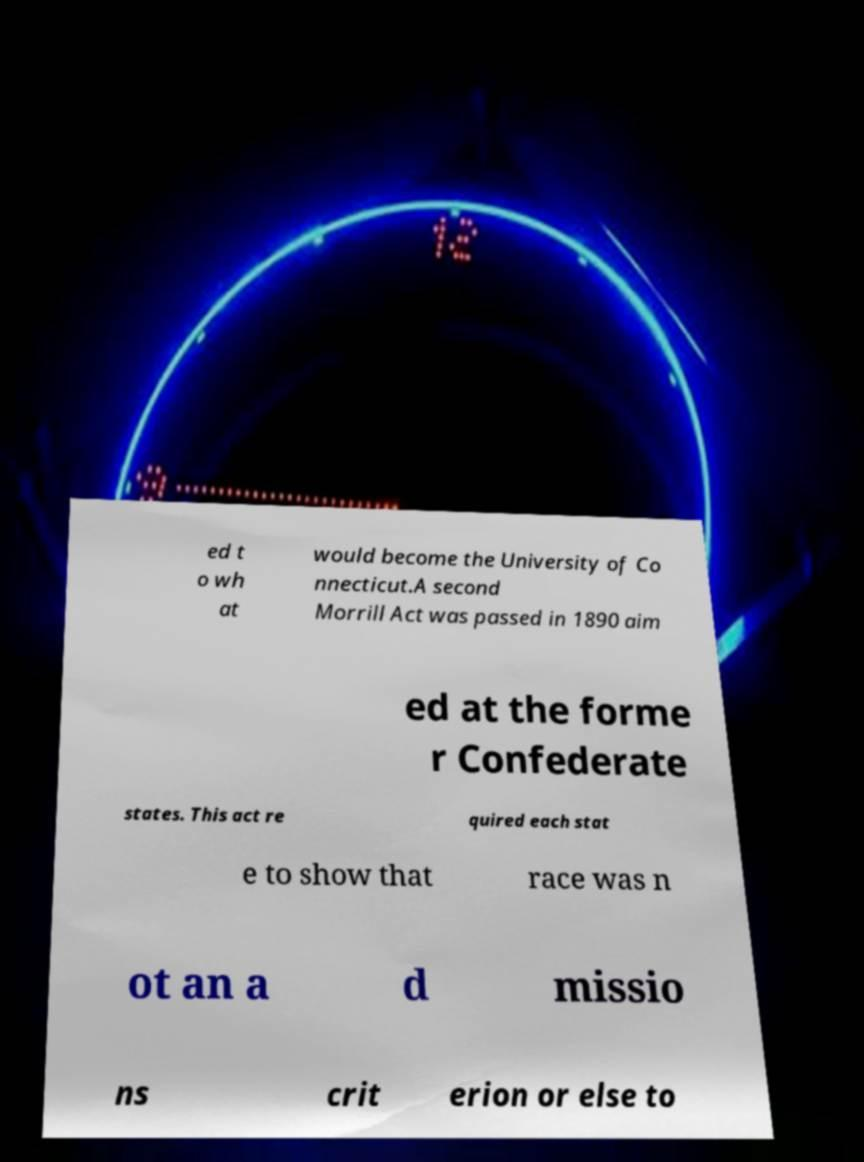There's text embedded in this image that I need extracted. Can you transcribe it verbatim? ed t o wh at would become the University of Co nnecticut.A second Morrill Act was passed in 1890 aim ed at the forme r Confederate states. This act re quired each stat e to show that race was n ot an a d missio ns crit erion or else to 